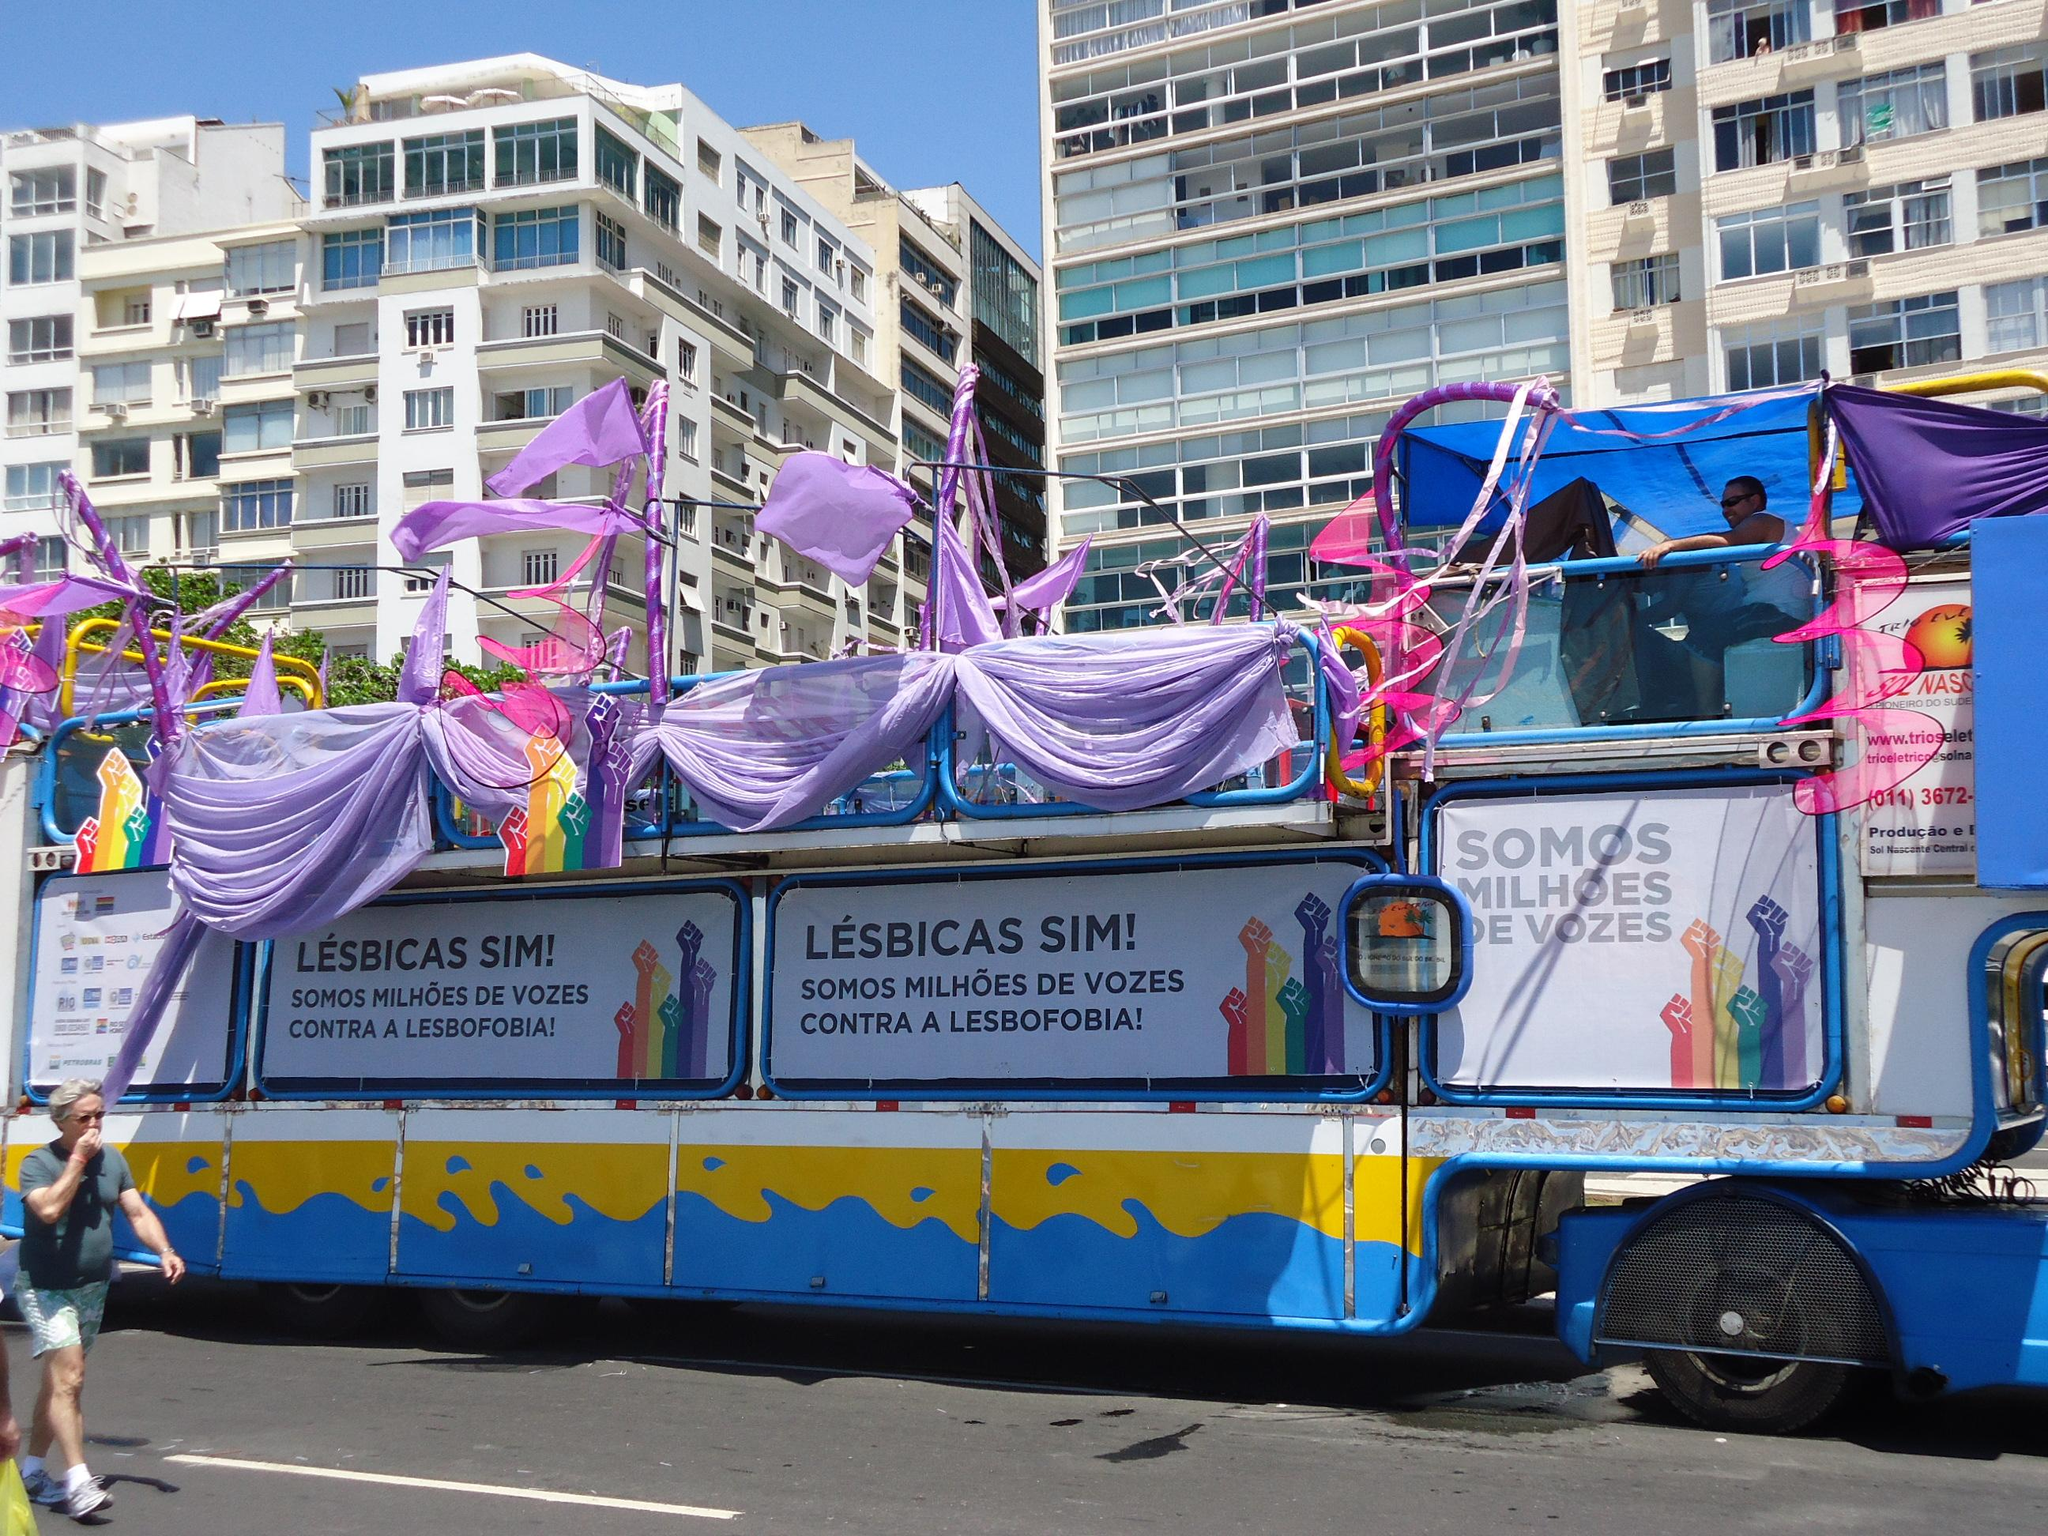What type of structures can be seen in the image? There are buildings in the image. What else is present on the road in the image? There is a vehicle on the road in the image. Can you identify any living beings in the image? Yes, there are people in the image. What can be seen in the distance in the image? The sky is visible in the background of the image. What type of chalk is being used by the people in the image? There is no chalk visible in the image. What is the relation between the people in the image? The provided facts do not give any information about the relationship between the people in the image. 